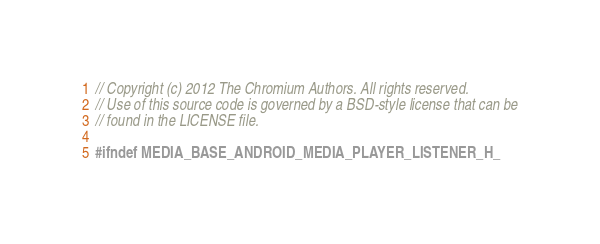<code> <loc_0><loc_0><loc_500><loc_500><_C_>// Copyright (c) 2012 The Chromium Authors. All rights reserved.
// Use of this source code is governed by a BSD-style license that can be
// found in the LICENSE file.

#ifndef MEDIA_BASE_ANDROID_MEDIA_PLAYER_LISTENER_H_</code> 